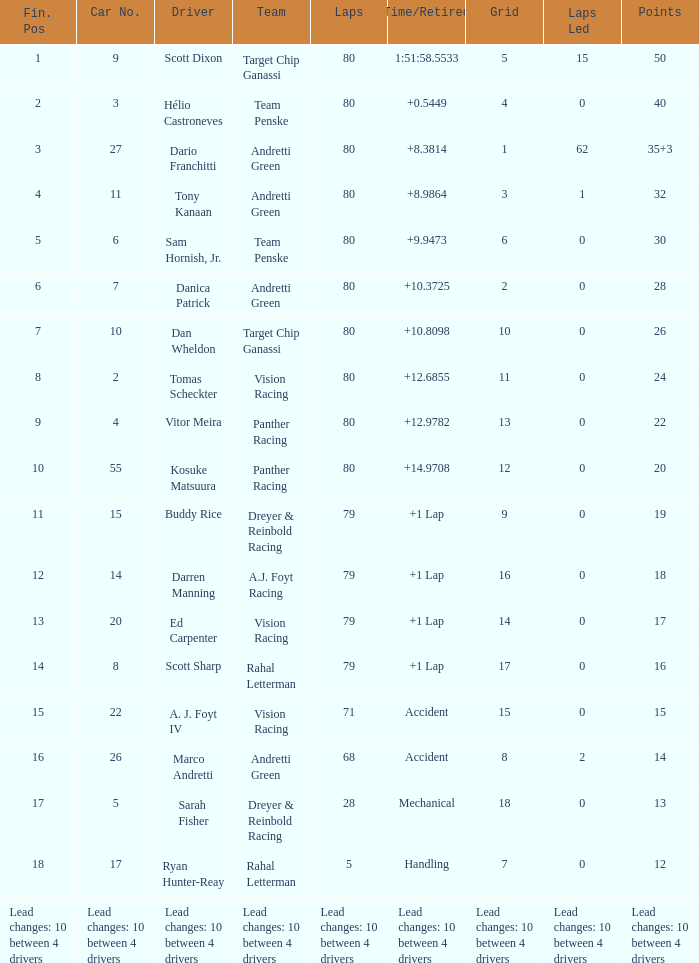Which team has 26 points? Target Chip Ganassi. 